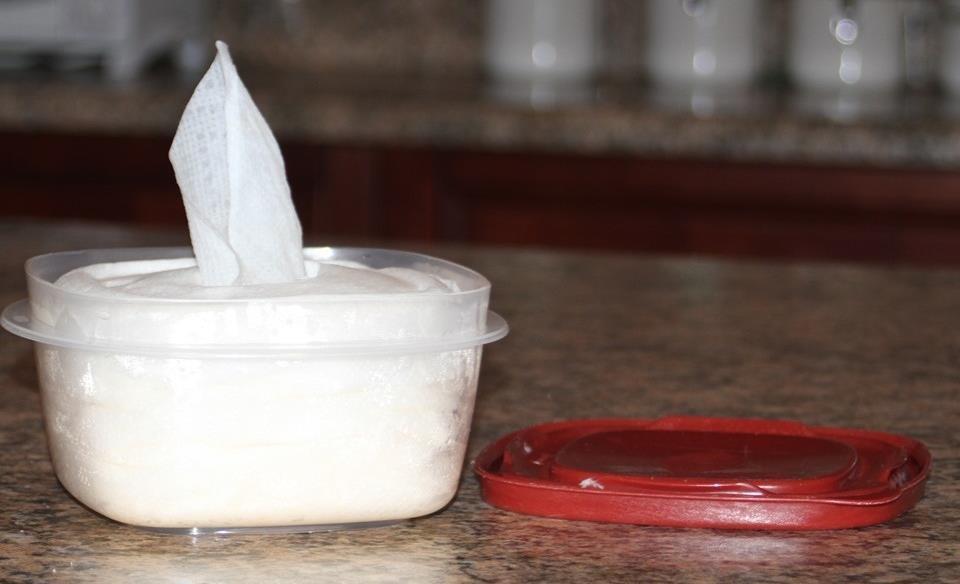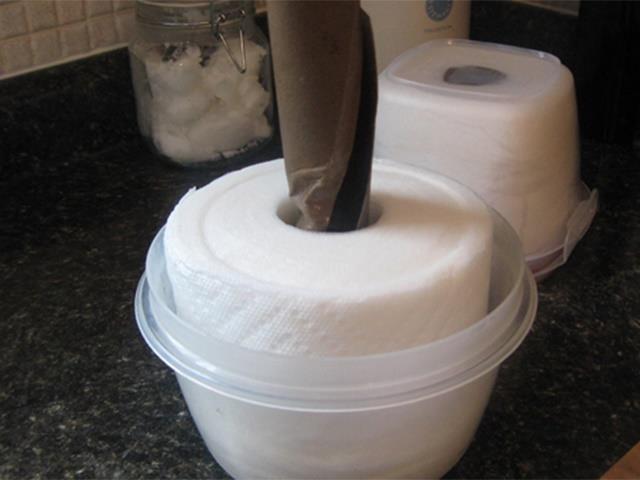The first image is the image on the left, the second image is the image on the right. Considering the images on both sides, is "The container in the image on the right is round." valid? Answer yes or no. Yes. 